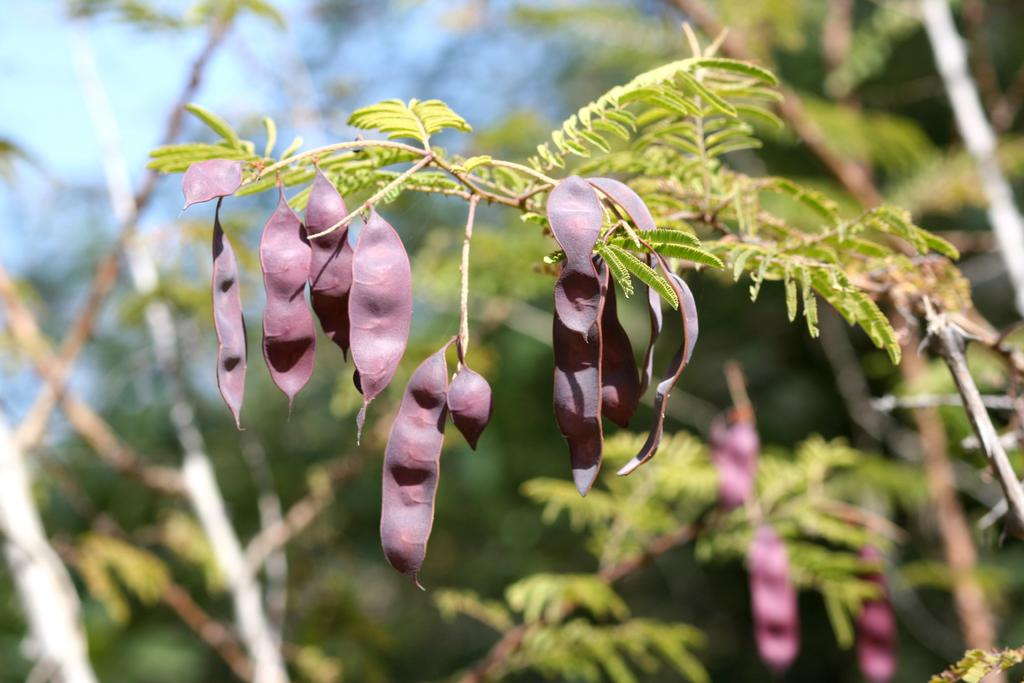What type of plant buds are visible in the image? There are tamarind buds in the image. What else can be seen on the tree branch in the image? There are leaves on the branch of a tree in the image. What type of powder is being used to season the beef in the image? There is no beef or powder present in the image; it only features tamarind buds and leaves on a tree branch. 